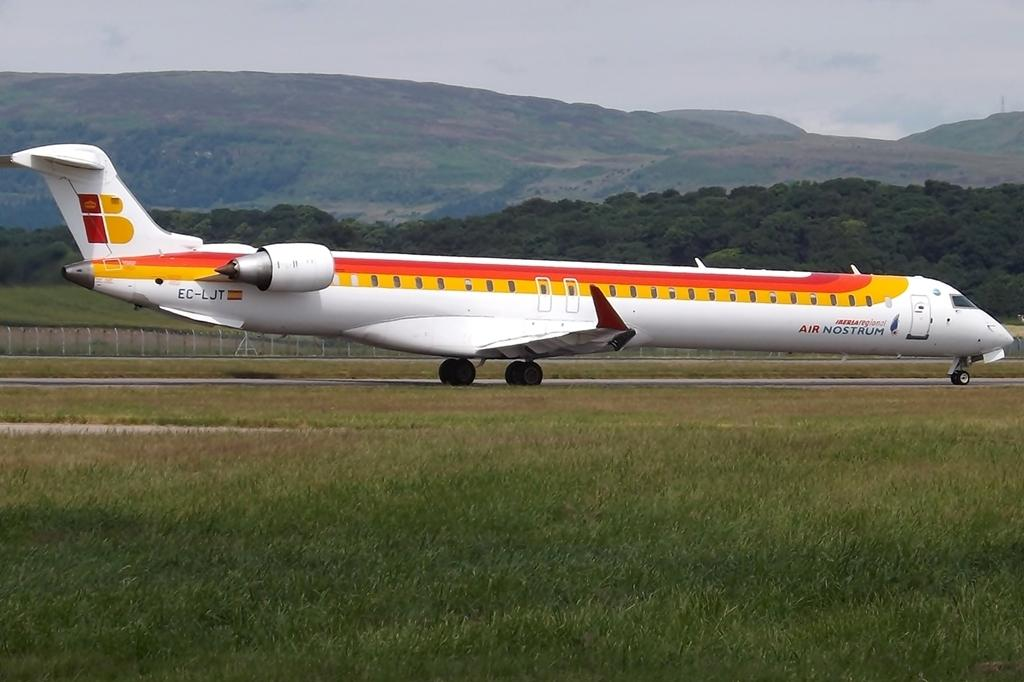<image>
Render a clear and concise summary of the photo. An orange, yellow and white airplane from the company Air Nostrum 